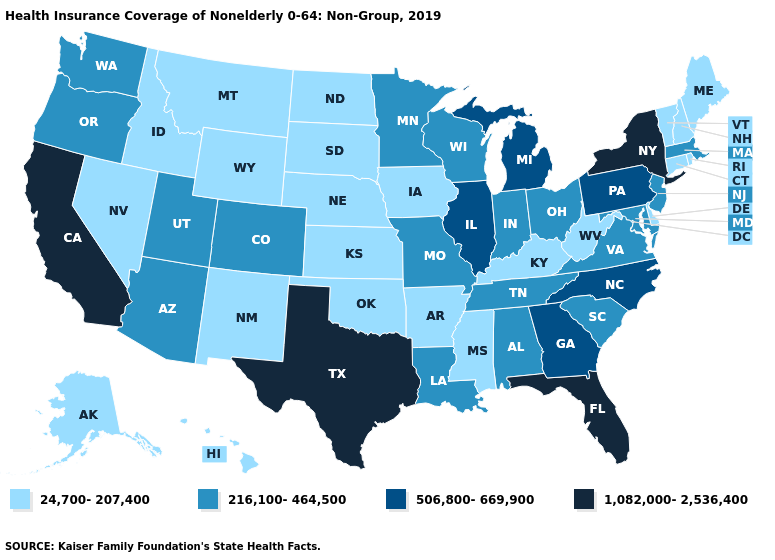Name the states that have a value in the range 24,700-207,400?
Concise answer only. Alaska, Arkansas, Connecticut, Delaware, Hawaii, Idaho, Iowa, Kansas, Kentucky, Maine, Mississippi, Montana, Nebraska, Nevada, New Hampshire, New Mexico, North Dakota, Oklahoma, Rhode Island, South Dakota, Vermont, West Virginia, Wyoming. Does Oklahoma have the lowest value in the South?
Short answer required. Yes. What is the value of California?
Give a very brief answer. 1,082,000-2,536,400. How many symbols are there in the legend?
Write a very short answer. 4. What is the value of Maine?
Be succinct. 24,700-207,400. What is the highest value in the USA?
Write a very short answer. 1,082,000-2,536,400. Name the states that have a value in the range 1,082,000-2,536,400?
Answer briefly. California, Florida, New York, Texas. Which states have the lowest value in the USA?
Give a very brief answer. Alaska, Arkansas, Connecticut, Delaware, Hawaii, Idaho, Iowa, Kansas, Kentucky, Maine, Mississippi, Montana, Nebraska, Nevada, New Hampshire, New Mexico, North Dakota, Oklahoma, Rhode Island, South Dakota, Vermont, West Virginia, Wyoming. Which states hav the highest value in the MidWest?
Keep it brief. Illinois, Michigan. What is the value of Wyoming?
Answer briefly. 24,700-207,400. What is the lowest value in the West?
Quick response, please. 24,700-207,400. Does Kentucky have the lowest value in the South?
Write a very short answer. Yes. Among the states that border Missouri , which have the highest value?
Be succinct. Illinois. What is the highest value in states that border Delaware?
Write a very short answer. 506,800-669,900. Does Illinois have the lowest value in the MidWest?
Be succinct. No. 